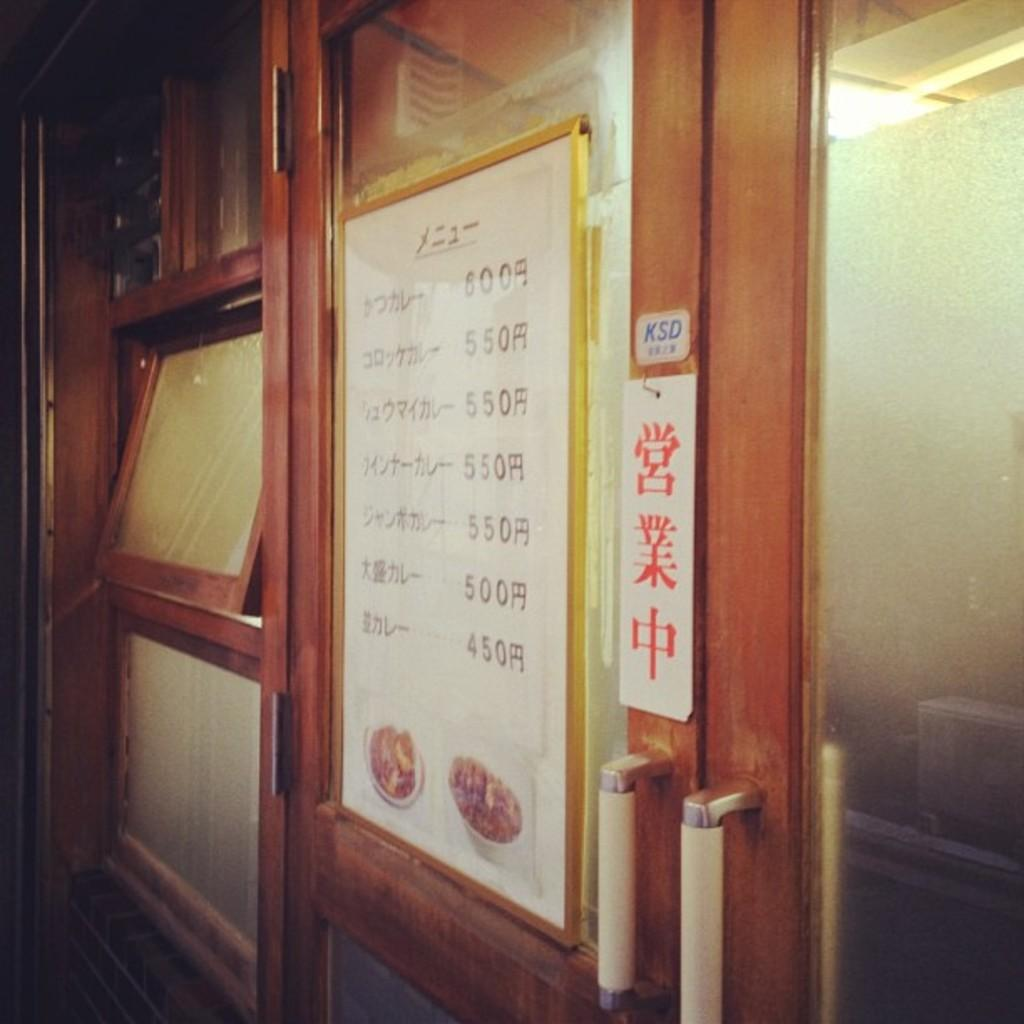What is one of the main features of the image? There is a door in the image. What can be seen on the menu board in the image? The menu board displays text and prices. Where are the windows located in the image? The windows are on the left side of the image. What type of copper material is used to make the face on the door in the image? There is no copper or face on the door in the image; it is a regular door without any decorative elements. Can you see a zipper on the menu board in the image? There is no zipper present on the menu board in the image. 